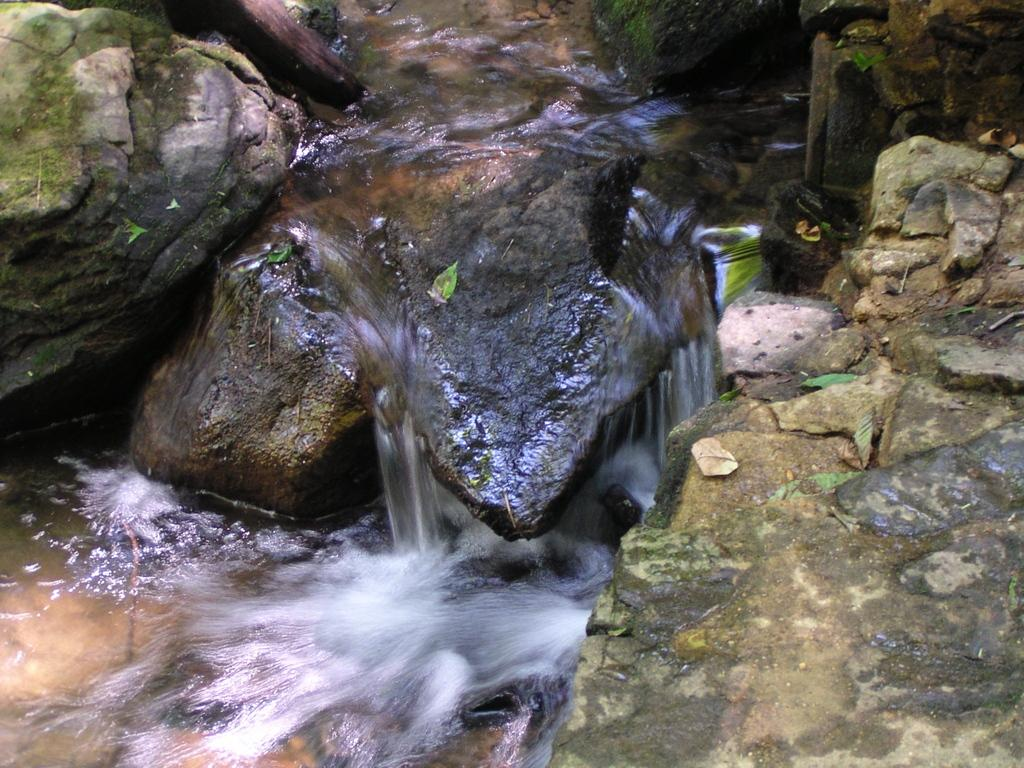What is the primary element in the picture? There is water in the picture. What other objects or features can be seen in the picture? There are rocks and leaves in the picture. What type of work is being done in the room depicted in the image? There is no room or any indication of work being done in the image; it features water, rocks, and leaves. 